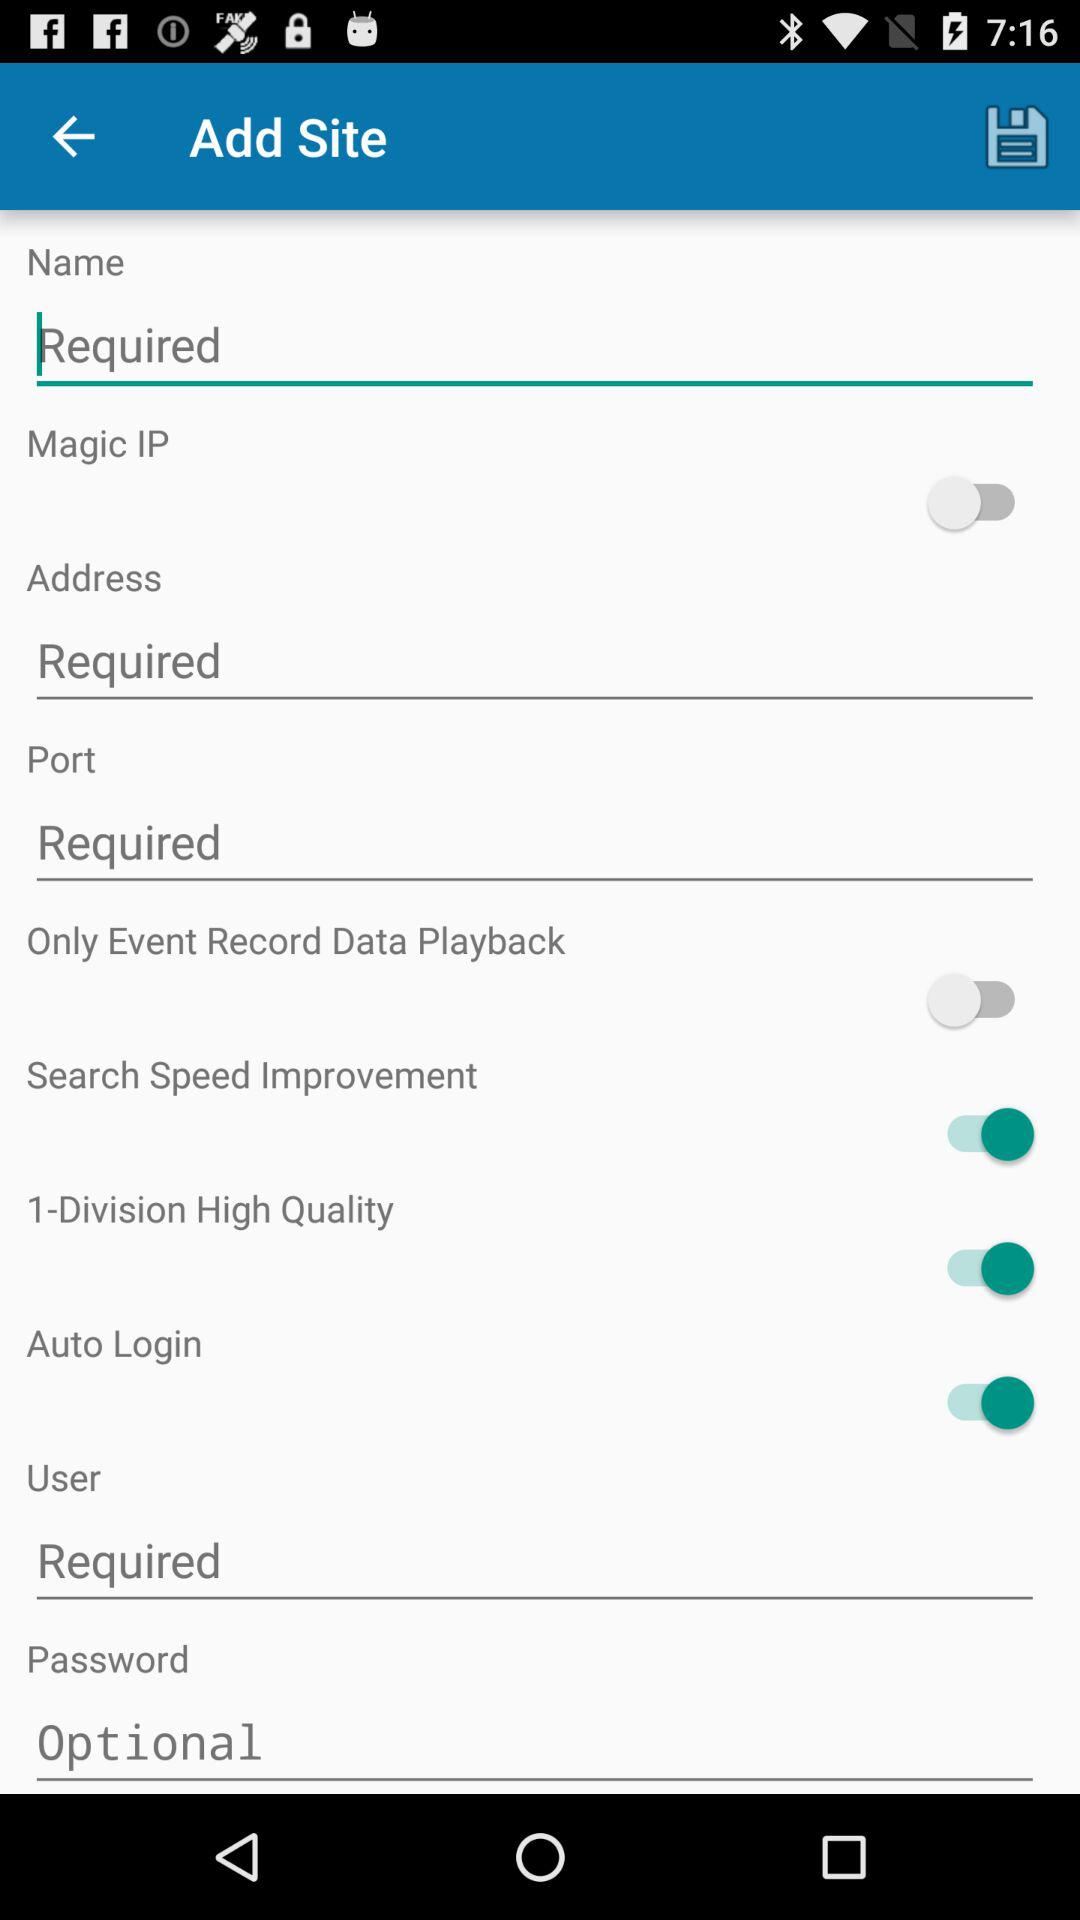What is the status of the "Search Speed Improvement"? The status is "on". 